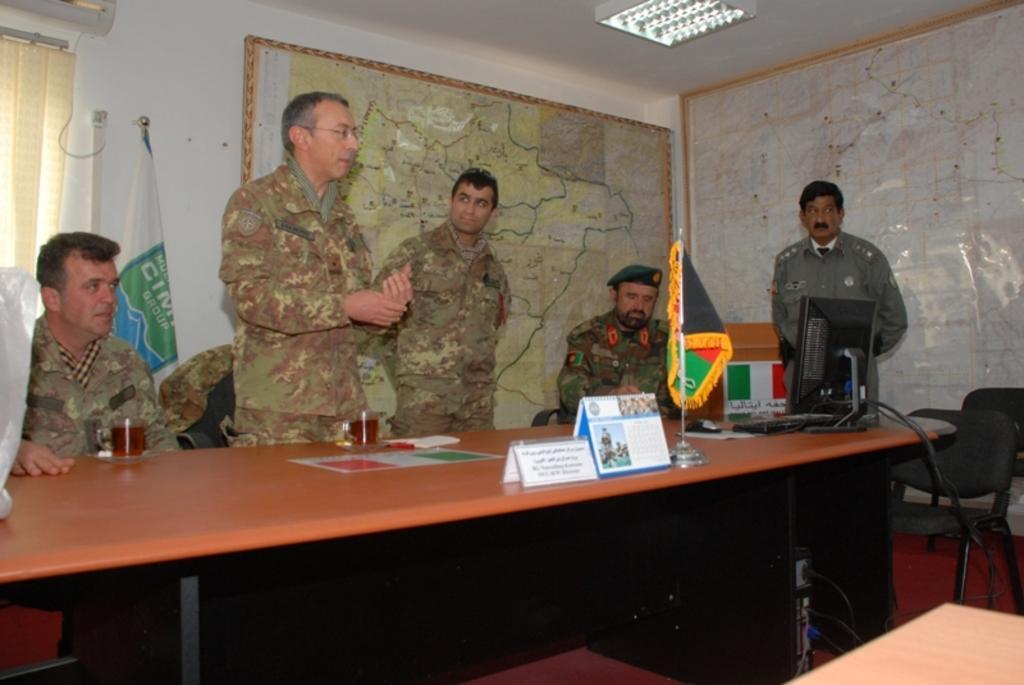Could you give a brief overview of what you see in this image? This image is clicked in a room where there are tables, chairs maps on the walls, there are lights on the top and the people are sitting around the table on chairs. all the people are wearing military dresses. on the table there are glasses, name boards, calendar, flag, computer. 